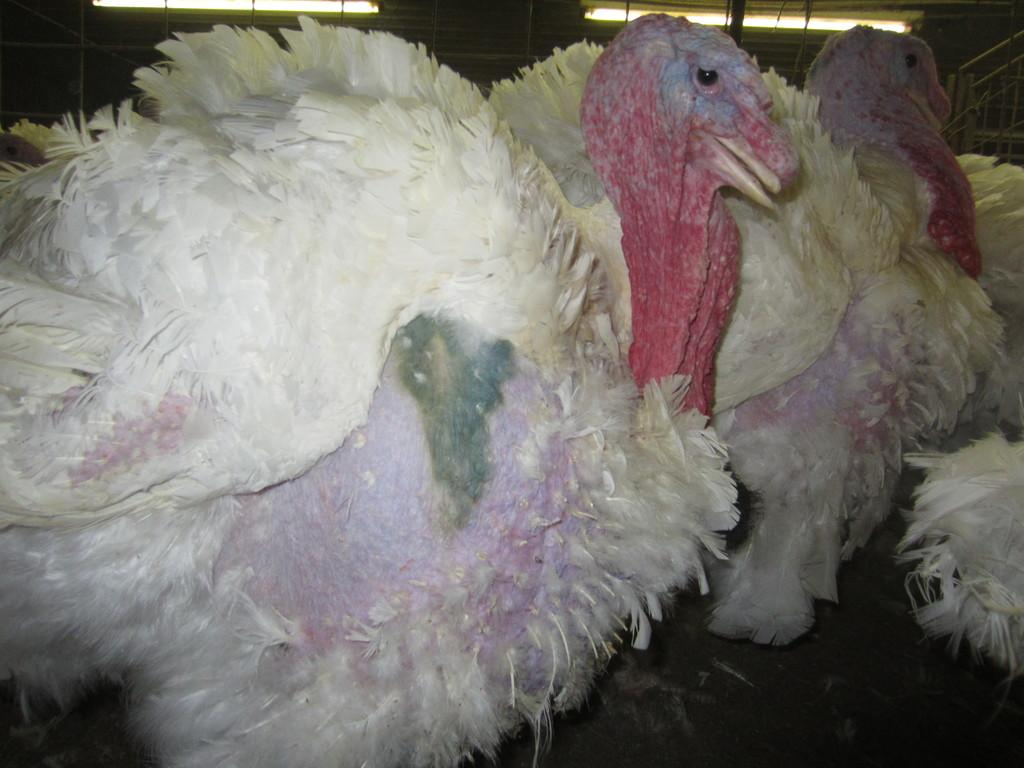What type of animals can be seen in the image? There are birds in the image. What can be seen in the background of the image? There are railings and poles in the background of the image. Are there any other objects visible in the background? Yes, there are other unspecified objects in the background of the image. What type of rail error is being displayed on the screen in the image? There is no screen or rail error present in the image; it features birds and background elements. 